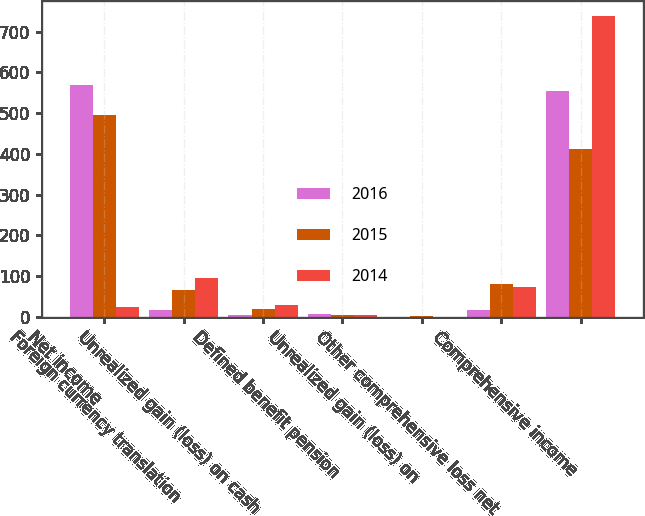Convert chart. <chart><loc_0><loc_0><loc_500><loc_500><stacked_bar_chart><ecel><fcel>Net income<fcel>Foreign currency translation<fcel>Unrealized gain (loss) on cash<fcel>Defined benefit pension<fcel>Unrealized gain (loss) on<fcel>Other comprehensive loss net<fcel>Comprehensive income<nl><fcel>2016<fcel>569.5<fcel>16.1<fcel>4.9<fcel>6.2<fcel>0.5<fcel>15.8<fcel>553.7<nl><fcel>2015<fcel>494.9<fcel>65.1<fcel>20.5<fcel>5.4<fcel>2.6<fcel>81.7<fcel>413.2<nl><fcel>2014<fcel>24.65<fcel>96.2<fcel>28.8<fcel>5.6<fcel>0.3<fcel>73.3<fcel>737.8<nl></chart> 